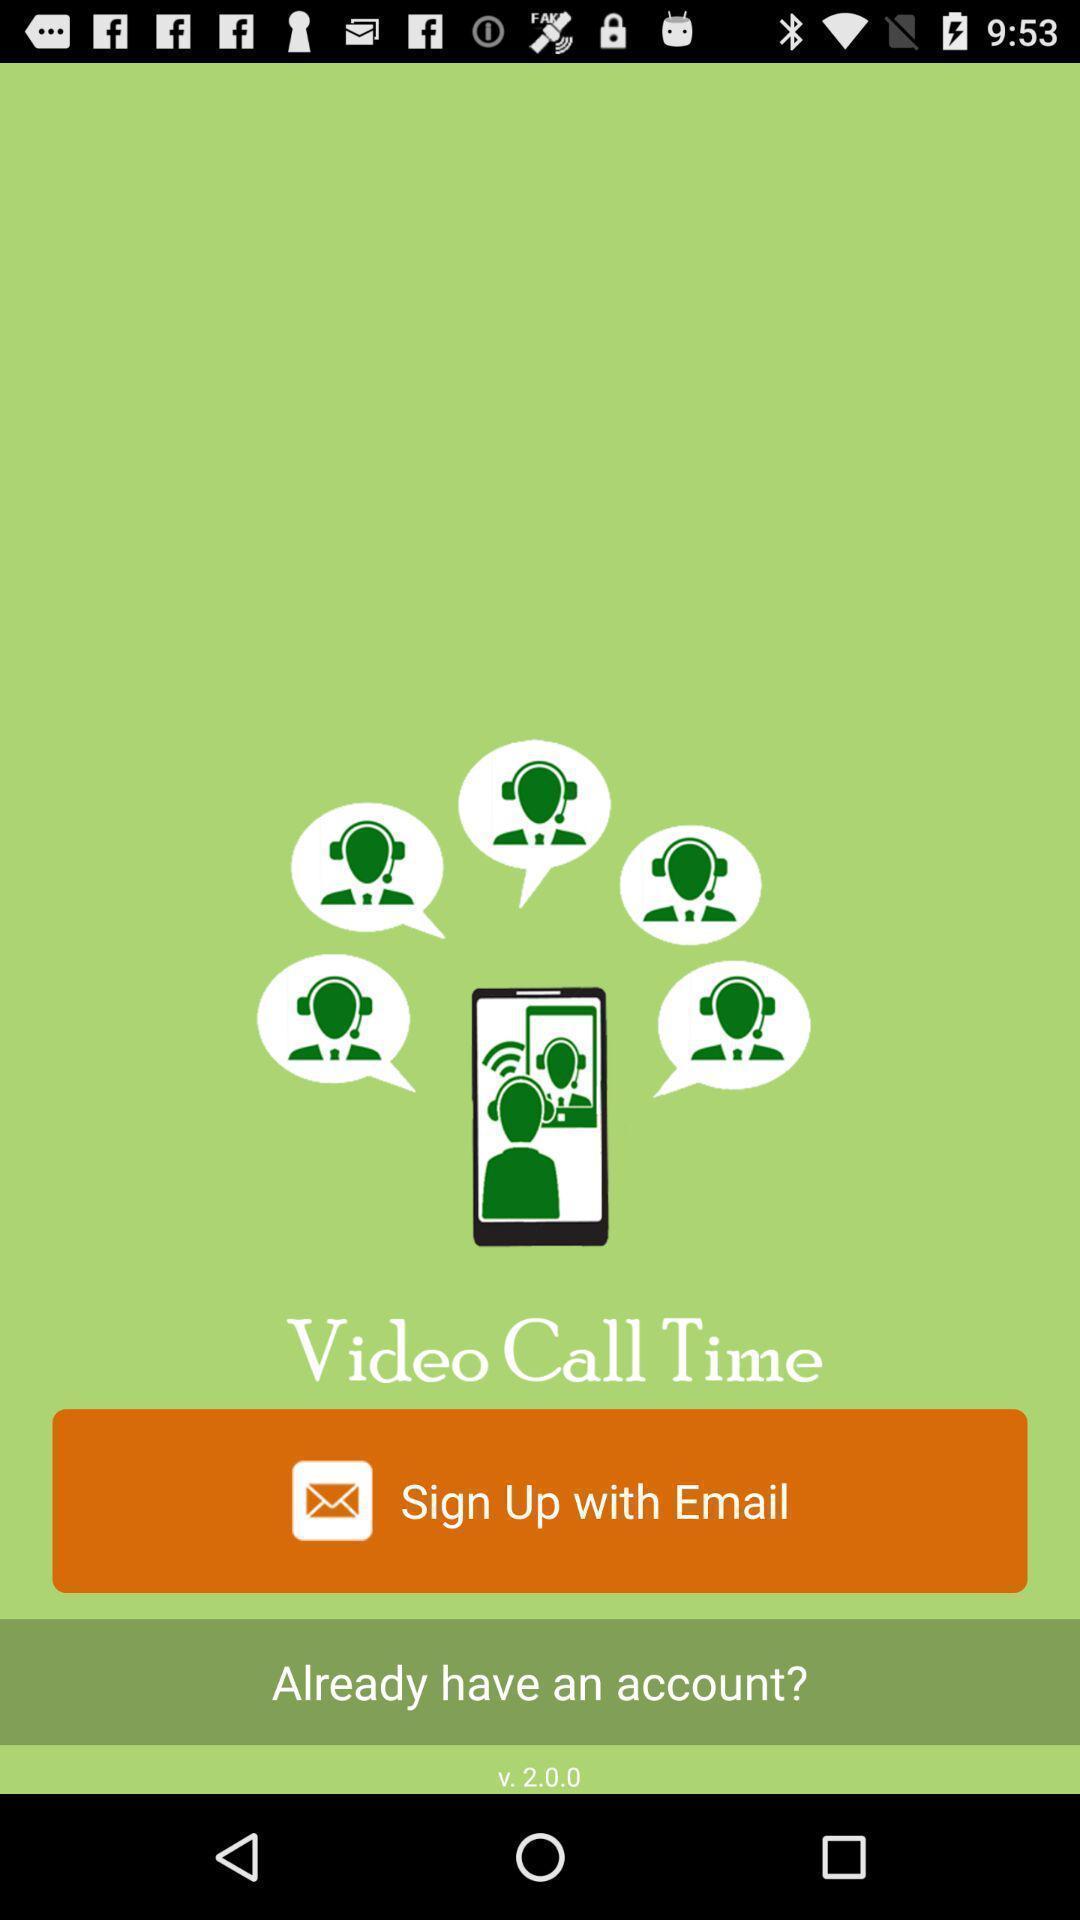Provide a description of this screenshot. Sign up page of a social app. 